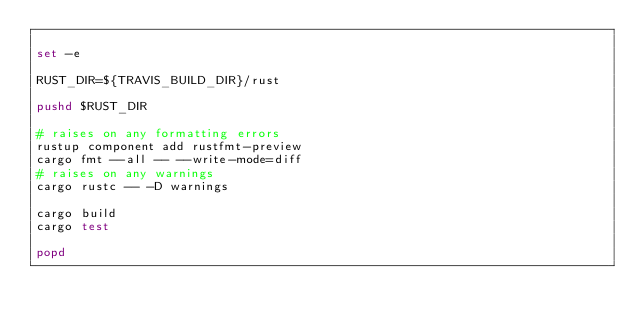<code> <loc_0><loc_0><loc_500><loc_500><_Bash_>
set -e

RUST_DIR=${TRAVIS_BUILD_DIR}/rust

pushd $RUST_DIR

# raises on any formatting errors
rustup component add rustfmt-preview
cargo fmt --all -- --write-mode=diff
# raises on any warnings
cargo rustc -- -D warnings

cargo build
cargo test

popd
</code> 